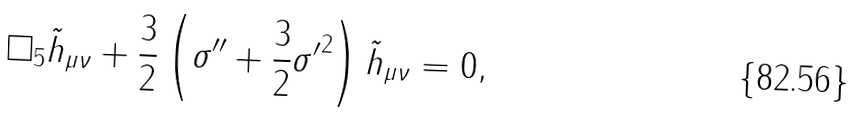<formula> <loc_0><loc_0><loc_500><loc_500>\Box _ { 5 } \tilde { h } _ { \mu \nu } + \frac { 3 } { 2 } \left ( \sigma ^ { \prime \prime } + \frac { 3 } { 2 } { \sigma ^ { \prime } } ^ { 2 } \right ) \tilde { h } _ { \mu \nu } = 0 ,</formula> 